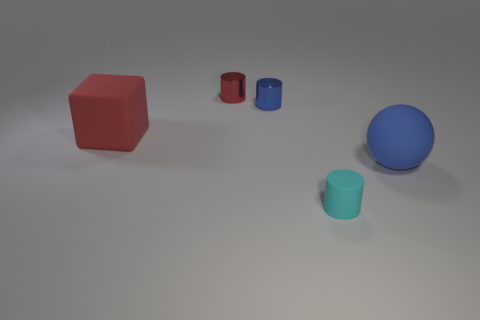Subtract all small metal cylinders. How many cylinders are left? 1 Add 3 cyan rubber cylinders. How many objects exist? 8 Subtract 1 cylinders. How many cylinders are left? 2 Subtract all cubes. How many objects are left? 4 Subtract all green cylinders. Subtract all brown blocks. How many cylinders are left? 3 Subtract all large red rubber blocks. Subtract all tiny metal cylinders. How many objects are left? 2 Add 5 big red things. How many big red things are left? 6 Add 2 tiny blue metallic cylinders. How many tiny blue metallic cylinders exist? 3 Subtract 0 brown cubes. How many objects are left? 5 